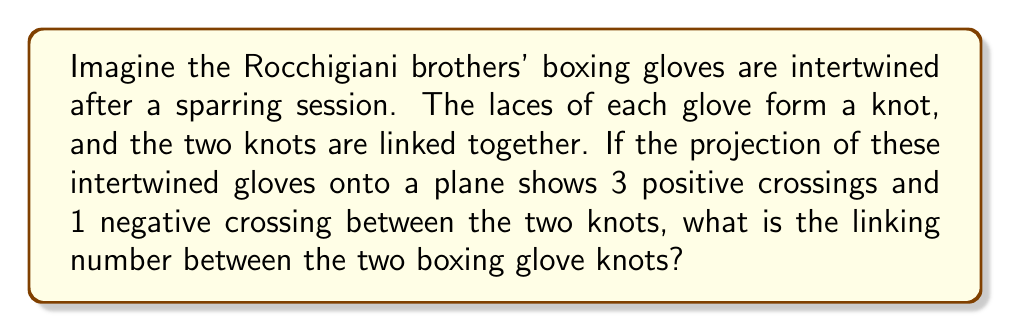Teach me how to tackle this problem. To determine the linking number between two knots, we follow these steps:

1. Identify the crossings: In this case, we have 3 positive crossings and 1 negative crossing between the two knots.

2. Calculate the linking number using the formula:

   $$Lk = \frac{1}{2}(n_+ - n_-)$$

   Where $Lk$ is the linking number, $n_+$ is the number of positive crossings, and $n_-$ is the number of negative crossings.

3. Substitute the values:
   $$Lk = \frac{1}{2}(3 - 1)$$

4. Simplify:
   $$Lk = \frac{1}{2}(2) = 1$$

The linking number is an integer or half-integer that measures how many times each knot winds around the other. In this case, the linking number of 1 indicates that the Rocchigiani brothers' boxing glove knots are linked once in a right-handed manner.
Answer: 1 